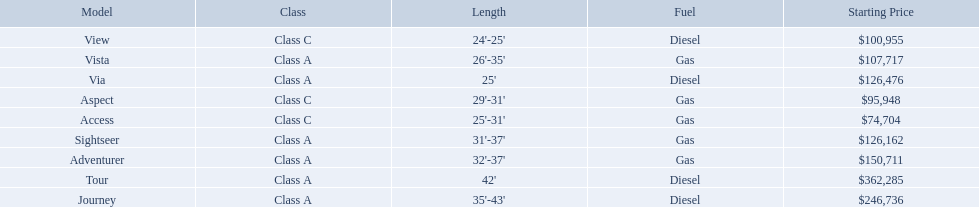Which model has the lowest starting price? Access. Which model has the second most highest starting price? Journey. Which model has the highest price in the winnebago industry? Tour. 